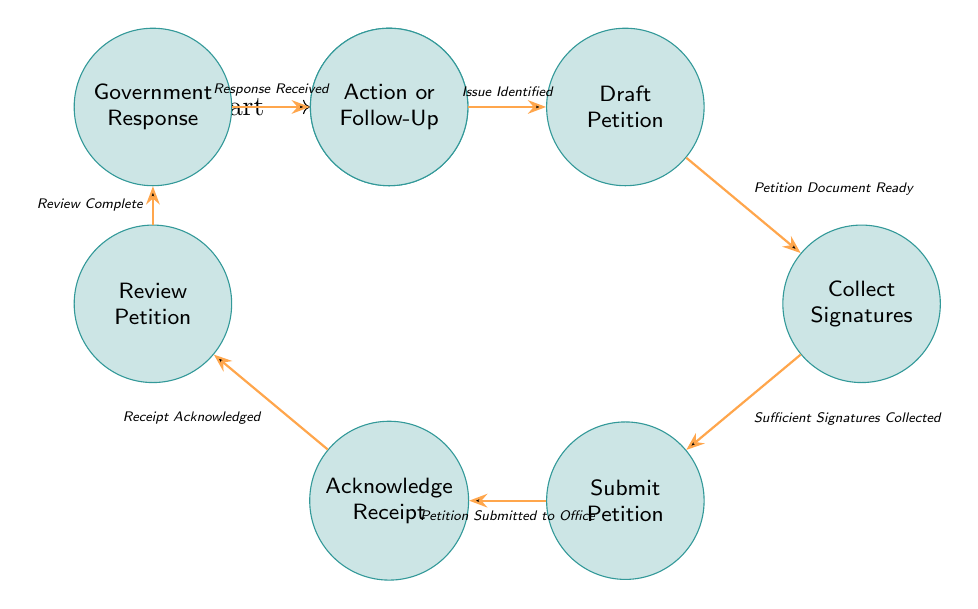What is the starting state of the workflow? The starting state is indicated as the initial node in the diagram, which is "Initiate Petition".
Answer: Initiate Petition How many total states are in the diagram? By counting each unique state represented in the diagram, we find there are eight states: Initiate Petition, Draft Petition, Collect Signatures, Submit Petition, Acknowledge Receipt, Review Petition, Government Response, and Action or Follow-Up.
Answer: Eight What is the trigger that moves from "Draft Petition" to "Collect Signatures"? This transition is facilitated by the trigger named "Petition Document Ready", which indicates that the drafting process has been completed.
Answer: Petition Document Ready Which state follows "Acknowledge Receipt"? From the diagram, the flow shows that the state that directly follows "Acknowledge Receipt" is "Review Petition".
Answer: Review Petition What is the last state in this workflow? The last state is identified as the final node in the diagram, which is "Action or Follow-Up", indicating the conclusion of the petition process.
Answer: Action or Follow-Up What is the total number of transitions in the diagram? By counting each transition that connects the states, we find there are seven transitions listed, illustrating the movement from one state to another.
Answer: Seven What happens after "Government Response"? After "Government Response", the next state is "Action or Follow-Up", where activists take action based on the government’s response to the petition.
Answer: Action or Follow-Up What is required to move from "Collect Signatures" to "Submit Petition"? The transition from "Collect Signatures" to "Submit Petition" occurs when "Sufficient Signatures Collected", indicating that enough support has been gathered to proceed.
Answer: Sufficient Signatures Collected 